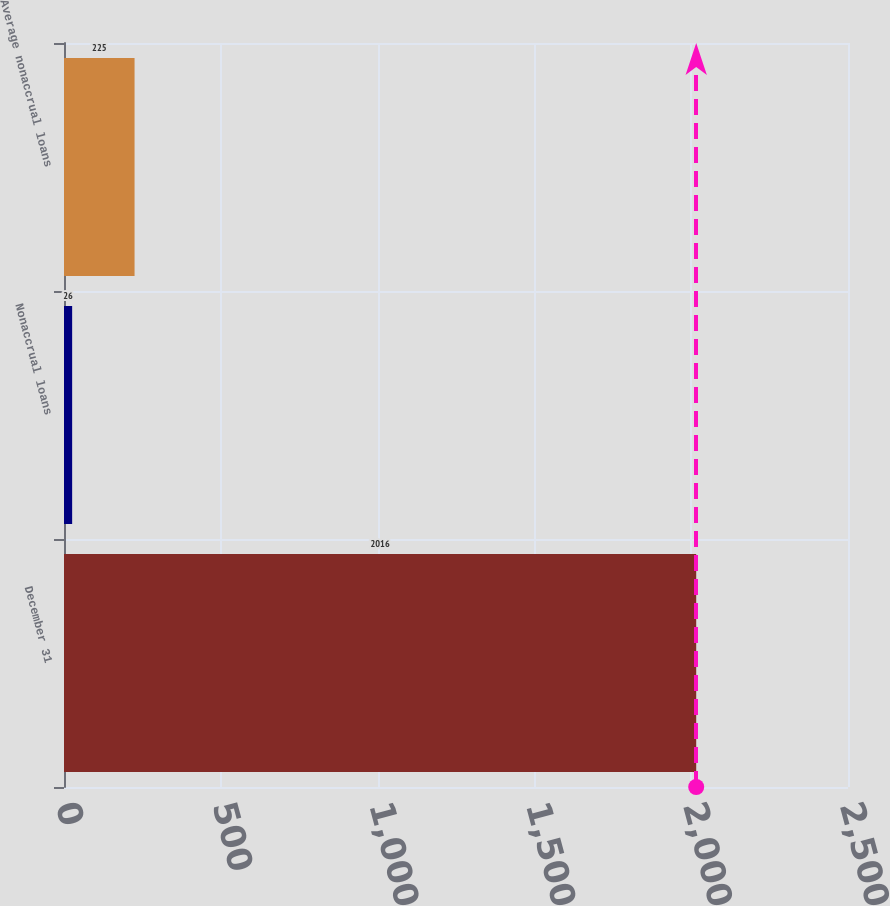Convert chart. <chart><loc_0><loc_0><loc_500><loc_500><bar_chart><fcel>December 31<fcel>Nonaccrual loans<fcel>Average nonaccrual loans<nl><fcel>2016<fcel>26<fcel>225<nl></chart> 